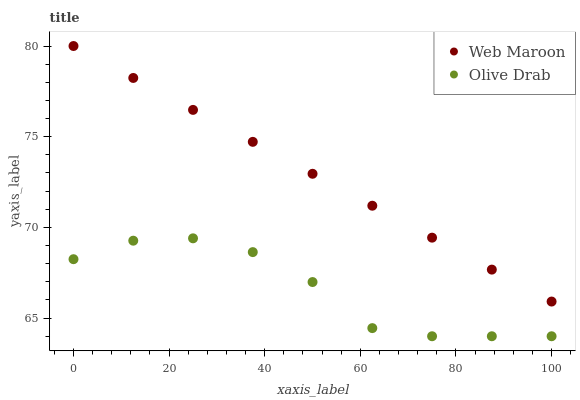Does Olive Drab have the minimum area under the curve?
Answer yes or no. Yes. Does Web Maroon have the maximum area under the curve?
Answer yes or no. Yes. Does Olive Drab have the maximum area under the curve?
Answer yes or no. No. Is Web Maroon the smoothest?
Answer yes or no. Yes. Is Olive Drab the roughest?
Answer yes or no. Yes. Is Olive Drab the smoothest?
Answer yes or no. No. Does Olive Drab have the lowest value?
Answer yes or no. Yes. Does Web Maroon have the highest value?
Answer yes or no. Yes. Does Olive Drab have the highest value?
Answer yes or no. No. Is Olive Drab less than Web Maroon?
Answer yes or no. Yes. Is Web Maroon greater than Olive Drab?
Answer yes or no. Yes. Does Olive Drab intersect Web Maroon?
Answer yes or no. No. 